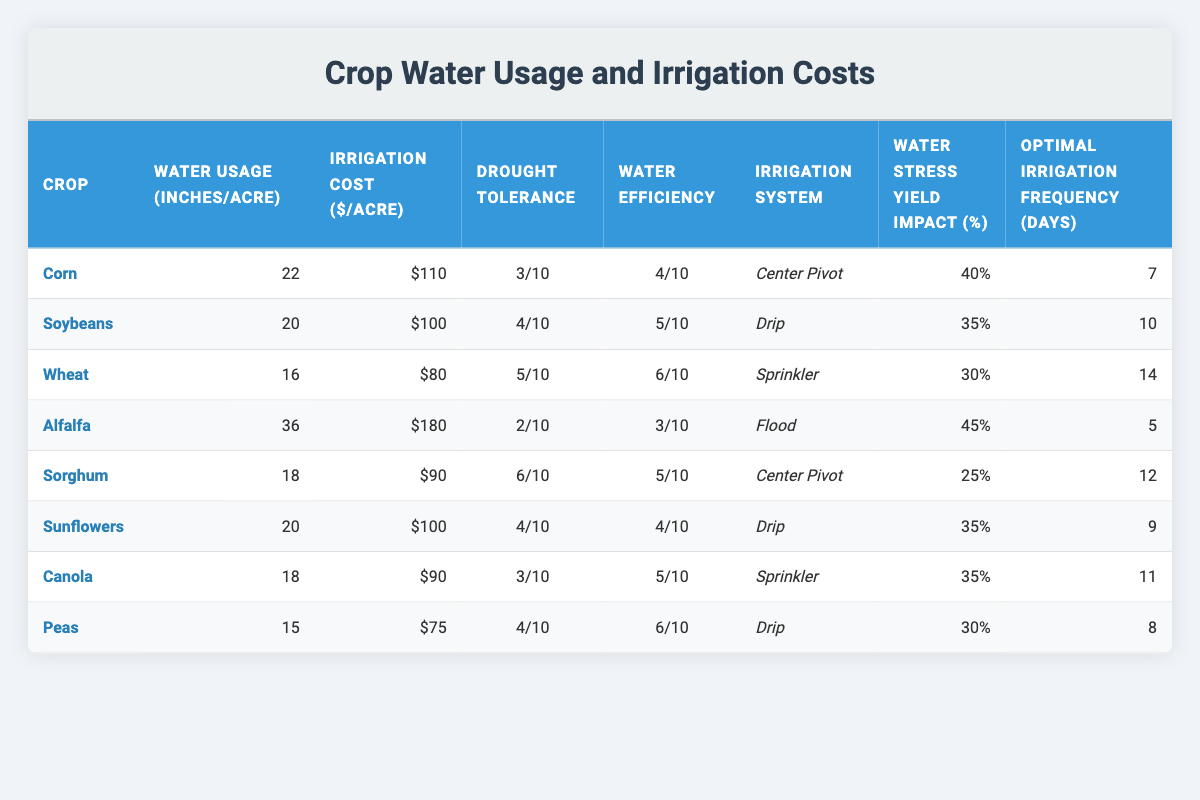What crop has the highest water usage per acre? Looking at the water usage values in the table, Alfalfa has the highest water usage at 36 inches per acre.
Answer: Alfalfa Which crop has the lowest irrigation cost per acre? By comparing the irrigation costs, Peas have the lowest cost at $75 per acre.
Answer: Peas What is the drought tolerance rating of Soybeans? Soybeans have a drought tolerance rating of 4 out of 10.
Answer: 4/10 What is the average water usage of all crops? Summing the water usage values: (22 + 20 + 16 + 36 + 18 + 20 + 18 + 15) = 165, and dividing by the number of crops (8), gives an average of 165/8 = 20.625 inches.
Answer: 20.625 inches How many crops have an irrigation cost greater than $100 per acre? The crops with an irrigation cost above $100 are Alfalfa ($180), Corn ($110), and Soybeans ($100). Hence, there are 3 crops.
Answer: 3 Which crop is associated with the least water stress yield impact percentage? Reviewing the water stress yield impact percentages, Sorghum has the smallest impact at 25%.
Answer: Sorghum Is the optimal irrigation frequency for Wheat less than that of Soybeans? For Wheat, the frequency is 14 days, while for Soybeans it is 10 days. Since 14 is greater than 10, this statement is false.
Answer: No What is the difference in irrigation cost between Corn and Sunflowers? The irrigation cost for Corn is $110 and for Sunflowers, it's $100. The difference is 110 - 100 = $10.
Answer: $10 Which crop has the highest water efficiency rating? Alfalfa, Corn, and Sorghum all have the highest water efficiency rating of 5 out of 10.
Answer: Alfalfa, Corn, Sorghum What is the optimal irrigation frequency for the crop with the highest drought tolerance? The crop with the highest drought tolerance is Sorghum with a rating of 6/10, and its optimal irrigation frequency is 12 days.
Answer: 12 days 